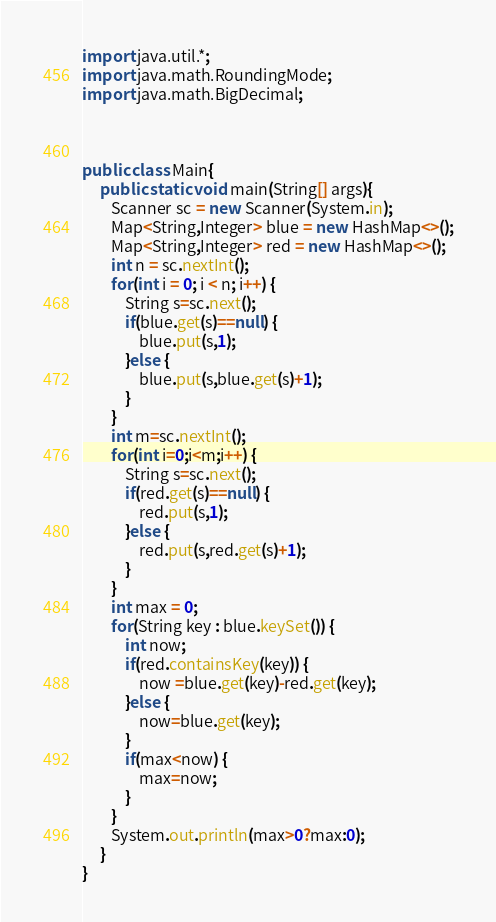Convert code to text. <code><loc_0><loc_0><loc_500><loc_500><_Java_>import java.util.*;
import java.math.RoundingMode;
import java.math.BigDecimal;
 
 
 
public class Main{
	 public static void main(String[] args){
		Scanner sc = new Scanner(System.in);
		Map<String,Integer> blue = new HashMap<>();
		Map<String,Integer> red = new HashMap<>();
		int n = sc.nextInt();
		for(int i = 0; i < n; i++) {
			String s=sc.next();
			if(blue.get(s)==null) {
				blue.put(s,1);
			}else {
				blue.put(s,blue.get(s)+1);
			}
		}
		int m=sc.nextInt();
		for(int i=0;i<m;i++) {
			String s=sc.next();
			if(red.get(s)==null) {
				red.put(s,1);
			}else {
				red.put(s,red.get(s)+1);
			}
		}
		int max = 0;
		for(String key : blue.keySet()) {
			int now;
			if(red.containsKey(key)) {
				now =blue.get(key)-red.get(key);
			}else {
				now=blue.get(key);
			}
			if(max<now) {
				max=now;
			}
		}
		System.out.println(max>0?max:0);
	 }
}</code> 